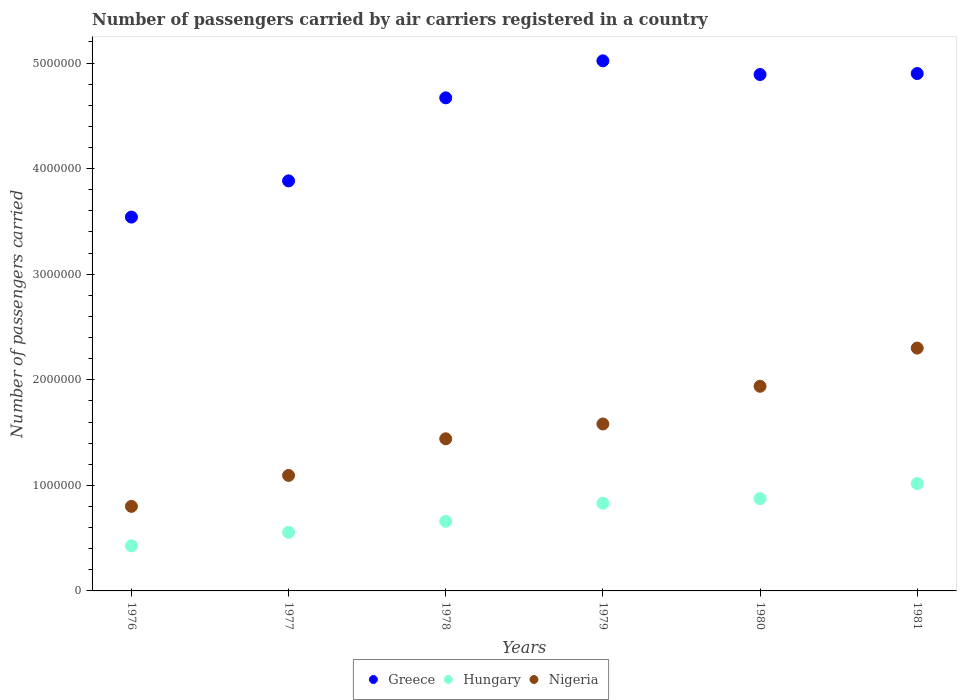How many different coloured dotlines are there?
Give a very brief answer. 3. What is the number of passengers carried by air carriers in Hungary in 1980?
Provide a succinct answer. 8.74e+05. Across all years, what is the maximum number of passengers carried by air carriers in Nigeria?
Offer a very short reply. 2.30e+06. Across all years, what is the minimum number of passengers carried by air carriers in Greece?
Your response must be concise. 3.54e+06. In which year was the number of passengers carried by air carriers in Greece maximum?
Ensure brevity in your answer.  1979. In which year was the number of passengers carried by air carriers in Nigeria minimum?
Your answer should be compact. 1976. What is the total number of passengers carried by air carriers in Nigeria in the graph?
Provide a short and direct response. 9.16e+06. What is the difference between the number of passengers carried by air carriers in Hungary in 1976 and that in 1980?
Offer a terse response. -4.47e+05. What is the difference between the number of passengers carried by air carriers in Greece in 1979 and the number of passengers carried by air carriers in Hungary in 1976?
Make the answer very short. 4.59e+06. What is the average number of passengers carried by air carriers in Hungary per year?
Your response must be concise. 7.27e+05. In the year 1977, what is the difference between the number of passengers carried by air carriers in Hungary and number of passengers carried by air carriers in Nigeria?
Provide a short and direct response. -5.39e+05. What is the ratio of the number of passengers carried by air carriers in Hungary in 1977 to that in 1980?
Offer a terse response. 0.63. Is the number of passengers carried by air carriers in Greece in 1976 less than that in 1977?
Your response must be concise. Yes. What is the difference between the highest and the second highest number of passengers carried by air carriers in Nigeria?
Your answer should be very brief. 3.62e+05. What is the difference between the highest and the lowest number of passengers carried by air carriers in Greece?
Give a very brief answer. 1.48e+06. Does the number of passengers carried by air carriers in Greece monotonically increase over the years?
Give a very brief answer. No. Is the number of passengers carried by air carriers in Hungary strictly greater than the number of passengers carried by air carriers in Nigeria over the years?
Your answer should be compact. No. Is the number of passengers carried by air carriers in Hungary strictly less than the number of passengers carried by air carriers in Greece over the years?
Your answer should be very brief. Yes. How many dotlines are there?
Your answer should be compact. 3. What is the difference between two consecutive major ticks on the Y-axis?
Make the answer very short. 1.00e+06. Does the graph contain any zero values?
Make the answer very short. No. Does the graph contain grids?
Give a very brief answer. No. How are the legend labels stacked?
Provide a short and direct response. Horizontal. What is the title of the graph?
Keep it short and to the point. Number of passengers carried by air carriers registered in a country. What is the label or title of the X-axis?
Provide a succinct answer. Years. What is the label or title of the Y-axis?
Your answer should be very brief. Number of passengers carried. What is the Number of passengers carried in Greece in 1976?
Offer a very short reply. 3.54e+06. What is the Number of passengers carried of Hungary in 1976?
Your answer should be very brief. 4.27e+05. What is the Number of passengers carried in Nigeria in 1976?
Keep it short and to the point. 8.01e+05. What is the Number of passengers carried of Greece in 1977?
Keep it short and to the point. 3.88e+06. What is the Number of passengers carried of Hungary in 1977?
Offer a very short reply. 5.55e+05. What is the Number of passengers carried of Nigeria in 1977?
Your response must be concise. 1.09e+06. What is the Number of passengers carried in Greece in 1978?
Provide a short and direct response. 4.67e+06. What is the Number of passengers carried in Hungary in 1978?
Give a very brief answer. 6.59e+05. What is the Number of passengers carried in Nigeria in 1978?
Offer a terse response. 1.44e+06. What is the Number of passengers carried in Greece in 1979?
Your response must be concise. 5.02e+06. What is the Number of passengers carried in Hungary in 1979?
Make the answer very short. 8.30e+05. What is the Number of passengers carried of Nigeria in 1979?
Provide a succinct answer. 1.58e+06. What is the Number of passengers carried in Greece in 1980?
Your answer should be very brief. 4.89e+06. What is the Number of passengers carried of Hungary in 1980?
Your answer should be compact. 8.74e+05. What is the Number of passengers carried of Nigeria in 1980?
Provide a short and direct response. 1.94e+06. What is the Number of passengers carried of Greece in 1981?
Your response must be concise. 4.90e+06. What is the Number of passengers carried of Hungary in 1981?
Offer a terse response. 1.02e+06. What is the Number of passengers carried of Nigeria in 1981?
Ensure brevity in your answer.  2.30e+06. Across all years, what is the maximum Number of passengers carried in Greece?
Provide a succinct answer. 5.02e+06. Across all years, what is the maximum Number of passengers carried of Hungary?
Offer a very short reply. 1.02e+06. Across all years, what is the maximum Number of passengers carried in Nigeria?
Your response must be concise. 2.30e+06. Across all years, what is the minimum Number of passengers carried of Greece?
Your answer should be very brief. 3.54e+06. Across all years, what is the minimum Number of passengers carried of Hungary?
Provide a succinct answer. 4.27e+05. Across all years, what is the minimum Number of passengers carried in Nigeria?
Offer a terse response. 8.01e+05. What is the total Number of passengers carried of Greece in the graph?
Provide a short and direct response. 2.69e+07. What is the total Number of passengers carried of Hungary in the graph?
Give a very brief answer. 4.36e+06. What is the total Number of passengers carried of Nigeria in the graph?
Keep it short and to the point. 9.16e+06. What is the difference between the Number of passengers carried in Greece in 1976 and that in 1977?
Offer a terse response. -3.43e+05. What is the difference between the Number of passengers carried in Hungary in 1976 and that in 1977?
Provide a short and direct response. -1.28e+05. What is the difference between the Number of passengers carried in Nigeria in 1976 and that in 1977?
Ensure brevity in your answer.  -2.93e+05. What is the difference between the Number of passengers carried of Greece in 1976 and that in 1978?
Keep it short and to the point. -1.13e+06. What is the difference between the Number of passengers carried of Hungary in 1976 and that in 1978?
Ensure brevity in your answer.  -2.32e+05. What is the difference between the Number of passengers carried in Nigeria in 1976 and that in 1978?
Your response must be concise. -6.40e+05. What is the difference between the Number of passengers carried in Greece in 1976 and that in 1979?
Offer a very short reply. -1.48e+06. What is the difference between the Number of passengers carried in Hungary in 1976 and that in 1979?
Your answer should be very brief. -4.03e+05. What is the difference between the Number of passengers carried in Nigeria in 1976 and that in 1979?
Make the answer very short. -7.80e+05. What is the difference between the Number of passengers carried in Greece in 1976 and that in 1980?
Ensure brevity in your answer.  -1.35e+06. What is the difference between the Number of passengers carried of Hungary in 1976 and that in 1980?
Offer a very short reply. -4.47e+05. What is the difference between the Number of passengers carried of Nigeria in 1976 and that in 1980?
Your answer should be very brief. -1.14e+06. What is the difference between the Number of passengers carried of Greece in 1976 and that in 1981?
Provide a short and direct response. -1.36e+06. What is the difference between the Number of passengers carried in Hungary in 1976 and that in 1981?
Your response must be concise. -5.90e+05. What is the difference between the Number of passengers carried in Nigeria in 1976 and that in 1981?
Offer a very short reply. -1.50e+06. What is the difference between the Number of passengers carried of Greece in 1977 and that in 1978?
Your answer should be very brief. -7.87e+05. What is the difference between the Number of passengers carried of Hungary in 1977 and that in 1978?
Offer a terse response. -1.04e+05. What is the difference between the Number of passengers carried in Nigeria in 1977 and that in 1978?
Make the answer very short. -3.47e+05. What is the difference between the Number of passengers carried of Greece in 1977 and that in 1979?
Ensure brevity in your answer.  -1.14e+06. What is the difference between the Number of passengers carried in Hungary in 1977 and that in 1979?
Offer a terse response. -2.75e+05. What is the difference between the Number of passengers carried in Nigeria in 1977 and that in 1979?
Make the answer very short. -4.87e+05. What is the difference between the Number of passengers carried of Greece in 1977 and that in 1980?
Your answer should be very brief. -1.01e+06. What is the difference between the Number of passengers carried in Hungary in 1977 and that in 1980?
Provide a short and direct response. -3.19e+05. What is the difference between the Number of passengers carried of Nigeria in 1977 and that in 1980?
Your answer should be compact. -8.45e+05. What is the difference between the Number of passengers carried of Greece in 1977 and that in 1981?
Your answer should be compact. -1.02e+06. What is the difference between the Number of passengers carried in Hungary in 1977 and that in 1981?
Your response must be concise. -4.62e+05. What is the difference between the Number of passengers carried in Nigeria in 1977 and that in 1981?
Ensure brevity in your answer.  -1.21e+06. What is the difference between the Number of passengers carried in Greece in 1978 and that in 1979?
Provide a succinct answer. -3.51e+05. What is the difference between the Number of passengers carried in Hungary in 1978 and that in 1979?
Your answer should be compact. -1.71e+05. What is the difference between the Number of passengers carried of Nigeria in 1978 and that in 1979?
Provide a succinct answer. -1.40e+05. What is the difference between the Number of passengers carried of Greece in 1978 and that in 1980?
Make the answer very short. -2.21e+05. What is the difference between the Number of passengers carried in Hungary in 1978 and that in 1980?
Make the answer very short. -2.15e+05. What is the difference between the Number of passengers carried in Nigeria in 1978 and that in 1980?
Give a very brief answer. -4.98e+05. What is the difference between the Number of passengers carried in Greece in 1978 and that in 1981?
Your answer should be compact. -2.30e+05. What is the difference between the Number of passengers carried in Hungary in 1978 and that in 1981?
Keep it short and to the point. -3.58e+05. What is the difference between the Number of passengers carried in Nigeria in 1978 and that in 1981?
Give a very brief answer. -8.59e+05. What is the difference between the Number of passengers carried of Greece in 1979 and that in 1980?
Give a very brief answer. 1.30e+05. What is the difference between the Number of passengers carried in Hungary in 1979 and that in 1980?
Keep it short and to the point. -4.41e+04. What is the difference between the Number of passengers carried in Nigeria in 1979 and that in 1980?
Your answer should be compact. -3.57e+05. What is the difference between the Number of passengers carried of Greece in 1979 and that in 1981?
Ensure brevity in your answer.  1.20e+05. What is the difference between the Number of passengers carried of Hungary in 1979 and that in 1981?
Your answer should be very brief. -1.87e+05. What is the difference between the Number of passengers carried in Nigeria in 1979 and that in 1981?
Provide a succinct answer. -7.19e+05. What is the difference between the Number of passengers carried in Greece in 1980 and that in 1981?
Provide a short and direct response. -9400. What is the difference between the Number of passengers carried in Hungary in 1980 and that in 1981?
Your answer should be compact. -1.43e+05. What is the difference between the Number of passengers carried of Nigeria in 1980 and that in 1981?
Make the answer very short. -3.62e+05. What is the difference between the Number of passengers carried in Greece in 1976 and the Number of passengers carried in Hungary in 1977?
Your response must be concise. 2.99e+06. What is the difference between the Number of passengers carried of Greece in 1976 and the Number of passengers carried of Nigeria in 1977?
Your response must be concise. 2.45e+06. What is the difference between the Number of passengers carried of Hungary in 1976 and the Number of passengers carried of Nigeria in 1977?
Your answer should be compact. -6.67e+05. What is the difference between the Number of passengers carried of Greece in 1976 and the Number of passengers carried of Hungary in 1978?
Ensure brevity in your answer.  2.88e+06. What is the difference between the Number of passengers carried in Greece in 1976 and the Number of passengers carried in Nigeria in 1978?
Provide a short and direct response. 2.10e+06. What is the difference between the Number of passengers carried in Hungary in 1976 and the Number of passengers carried in Nigeria in 1978?
Your answer should be very brief. -1.01e+06. What is the difference between the Number of passengers carried in Greece in 1976 and the Number of passengers carried in Hungary in 1979?
Your answer should be compact. 2.71e+06. What is the difference between the Number of passengers carried of Greece in 1976 and the Number of passengers carried of Nigeria in 1979?
Your response must be concise. 1.96e+06. What is the difference between the Number of passengers carried in Hungary in 1976 and the Number of passengers carried in Nigeria in 1979?
Offer a very short reply. -1.15e+06. What is the difference between the Number of passengers carried of Greece in 1976 and the Number of passengers carried of Hungary in 1980?
Provide a short and direct response. 2.67e+06. What is the difference between the Number of passengers carried in Greece in 1976 and the Number of passengers carried in Nigeria in 1980?
Offer a terse response. 1.60e+06. What is the difference between the Number of passengers carried in Hungary in 1976 and the Number of passengers carried in Nigeria in 1980?
Provide a succinct answer. -1.51e+06. What is the difference between the Number of passengers carried of Greece in 1976 and the Number of passengers carried of Hungary in 1981?
Offer a terse response. 2.52e+06. What is the difference between the Number of passengers carried of Greece in 1976 and the Number of passengers carried of Nigeria in 1981?
Make the answer very short. 1.24e+06. What is the difference between the Number of passengers carried of Hungary in 1976 and the Number of passengers carried of Nigeria in 1981?
Your response must be concise. -1.87e+06. What is the difference between the Number of passengers carried in Greece in 1977 and the Number of passengers carried in Hungary in 1978?
Provide a succinct answer. 3.22e+06. What is the difference between the Number of passengers carried of Greece in 1977 and the Number of passengers carried of Nigeria in 1978?
Your answer should be very brief. 2.44e+06. What is the difference between the Number of passengers carried of Hungary in 1977 and the Number of passengers carried of Nigeria in 1978?
Give a very brief answer. -8.86e+05. What is the difference between the Number of passengers carried in Greece in 1977 and the Number of passengers carried in Hungary in 1979?
Provide a succinct answer. 3.05e+06. What is the difference between the Number of passengers carried of Greece in 1977 and the Number of passengers carried of Nigeria in 1979?
Make the answer very short. 2.30e+06. What is the difference between the Number of passengers carried in Hungary in 1977 and the Number of passengers carried in Nigeria in 1979?
Your answer should be compact. -1.03e+06. What is the difference between the Number of passengers carried of Greece in 1977 and the Number of passengers carried of Hungary in 1980?
Offer a terse response. 3.01e+06. What is the difference between the Number of passengers carried in Greece in 1977 and the Number of passengers carried in Nigeria in 1980?
Keep it short and to the point. 1.95e+06. What is the difference between the Number of passengers carried of Hungary in 1977 and the Number of passengers carried of Nigeria in 1980?
Ensure brevity in your answer.  -1.38e+06. What is the difference between the Number of passengers carried of Greece in 1977 and the Number of passengers carried of Hungary in 1981?
Keep it short and to the point. 2.87e+06. What is the difference between the Number of passengers carried in Greece in 1977 and the Number of passengers carried in Nigeria in 1981?
Give a very brief answer. 1.58e+06. What is the difference between the Number of passengers carried in Hungary in 1977 and the Number of passengers carried in Nigeria in 1981?
Your answer should be compact. -1.75e+06. What is the difference between the Number of passengers carried of Greece in 1978 and the Number of passengers carried of Hungary in 1979?
Keep it short and to the point. 3.84e+06. What is the difference between the Number of passengers carried in Greece in 1978 and the Number of passengers carried in Nigeria in 1979?
Offer a very short reply. 3.09e+06. What is the difference between the Number of passengers carried in Hungary in 1978 and the Number of passengers carried in Nigeria in 1979?
Ensure brevity in your answer.  -9.22e+05. What is the difference between the Number of passengers carried in Greece in 1978 and the Number of passengers carried in Hungary in 1980?
Provide a succinct answer. 3.80e+06. What is the difference between the Number of passengers carried in Greece in 1978 and the Number of passengers carried in Nigeria in 1980?
Offer a very short reply. 2.73e+06. What is the difference between the Number of passengers carried of Hungary in 1978 and the Number of passengers carried of Nigeria in 1980?
Offer a terse response. -1.28e+06. What is the difference between the Number of passengers carried of Greece in 1978 and the Number of passengers carried of Hungary in 1981?
Provide a short and direct response. 3.65e+06. What is the difference between the Number of passengers carried of Greece in 1978 and the Number of passengers carried of Nigeria in 1981?
Your answer should be compact. 2.37e+06. What is the difference between the Number of passengers carried of Hungary in 1978 and the Number of passengers carried of Nigeria in 1981?
Your answer should be compact. -1.64e+06. What is the difference between the Number of passengers carried of Greece in 1979 and the Number of passengers carried of Hungary in 1980?
Provide a succinct answer. 4.15e+06. What is the difference between the Number of passengers carried in Greece in 1979 and the Number of passengers carried in Nigeria in 1980?
Keep it short and to the point. 3.08e+06. What is the difference between the Number of passengers carried in Hungary in 1979 and the Number of passengers carried in Nigeria in 1980?
Your answer should be very brief. -1.11e+06. What is the difference between the Number of passengers carried of Greece in 1979 and the Number of passengers carried of Hungary in 1981?
Ensure brevity in your answer.  4.00e+06. What is the difference between the Number of passengers carried in Greece in 1979 and the Number of passengers carried in Nigeria in 1981?
Your answer should be compact. 2.72e+06. What is the difference between the Number of passengers carried in Hungary in 1979 and the Number of passengers carried in Nigeria in 1981?
Your response must be concise. -1.47e+06. What is the difference between the Number of passengers carried in Greece in 1980 and the Number of passengers carried in Hungary in 1981?
Ensure brevity in your answer.  3.87e+06. What is the difference between the Number of passengers carried of Greece in 1980 and the Number of passengers carried of Nigeria in 1981?
Your answer should be very brief. 2.59e+06. What is the difference between the Number of passengers carried of Hungary in 1980 and the Number of passengers carried of Nigeria in 1981?
Offer a very short reply. -1.43e+06. What is the average Number of passengers carried of Greece per year?
Your answer should be very brief. 4.48e+06. What is the average Number of passengers carried in Hungary per year?
Make the answer very short. 7.27e+05. What is the average Number of passengers carried of Nigeria per year?
Give a very brief answer. 1.53e+06. In the year 1976, what is the difference between the Number of passengers carried of Greece and Number of passengers carried of Hungary?
Provide a succinct answer. 3.11e+06. In the year 1976, what is the difference between the Number of passengers carried in Greece and Number of passengers carried in Nigeria?
Ensure brevity in your answer.  2.74e+06. In the year 1976, what is the difference between the Number of passengers carried of Hungary and Number of passengers carried of Nigeria?
Provide a succinct answer. -3.74e+05. In the year 1977, what is the difference between the Number of passengers carried in Greece and Number of passengers carried in Hungary?
Offer a very short reply. 3.33e+06. In the year 1977, what is the difference between the Number of passengers carried in Greece and Number of passengers carried in Nigeria?
Offer a terse response. 2.79e+06. In the year 1977, what is the difference between the Number of passengers carried of Hungary and Number of passengers carried of Nigeria?
Offer a very short reply. -5.39e+05. In the year 1978, what is the difference between the Number of passengers carried of Greece and Number of passengers carried of Hungary?
Provide a short and direct response. 4.01e+06. In the year 1978, what is the difference between the Number of passengers carried of Greece and Number of passengers carried of Nigeria?
Give a very brief answer. 3.23e+06. In the year 1978, what is the difference between the Number of passengers carried in Hungary and Number of passengers carried in Nigeria?
Offer a terse response. -7.82e+05. In the year 1979, what is the difference between the Number of passengers carried of Greece and Number of passengers carried of Hungary?
Ensure brevity in your answer.  4.19e+06. In the year 1979, what is the difference between the Number of passengers carried in Greece and Number of passengers carried in Nigeria?
Ensure brevity in your answer.  3.44e+06. In the year 1979, what is the difference between the Number of passengers carried of Hungary and Number of passengers carried of Nigeria?
Offer a terse response. -7.51e+05. In the year 1980, what is the difference between the Number of passengers carried of Greece and Number of passengers carried of Hungary?
Your answer should be very brief. 4.02e+06. In the year 1980, what is the difference between the Number of passengers carried of Greece and Number of passengers carried of Nigeria?
Provide a short and direct response. 2.95e+06. In the year 1980, what is the difference between the Number of passengers carried in Hungary and Number of passengers carried in Nigeria?
Keep it short and to the point. -1.06e+06. In the year 1981, what is the difference between the Number of passengers carried in Greece and Number of passengers carried in Hungary?
Give a very brief answer. 3.88e+06. In the year 1981, what is the difference between the Number of passengers carried in Greece and Number of passengers carried in Nigeria?
Keep it short and to the point. 2.60e+06. In the year 1981, what is the difference between the Number of passengers carried in Hungary and Number of passengers carried in Nigeria?
Your answer should be very brief. -1.28e+06. What is the ratio of the Number of passengers carried of Greece in 1976 to that in 1977?
Provide a short and direct response. 0.91. What is the ratio of the Number of passengers carried in Hungary in 1976 to that in 1977?
Make the answer very short. 0.77. What is the ratio of the Number of passengers carried of Nigeria in 1976 to that in 1977?
Your response must be concise. 0.73. What is the ratio of the Number of passengers carried of Greece in 1976 to that in 1978?
Keep it short and to the point. 0.76. What is the ratio of the Number of passengers carried of Hungary in 1976 to that in 1978?
Your answer should be compact. 0.65. What is the ratio of the Number of passengers carried in Nigeria in 1976 to that in 1978?
Offer a terse response. 0.56. What is the ratio of the Number of passengers carried in Greece in 1976 to that in 1979?
Offer a terse response. 0.71. What is the ratio of the Number of passengers carried in Hungary in 1976 to that in 1979?
Keep it short and to the point. 0.51. What is the ratio of the Number of passengers carried of Nigeria in 1976 to that in 1979?
Keep it short and to the point. 0.51. What is the ratio of the Number of passengers carried in Greece in 1976 to that in 1980?
Give a very brief answer. 0.72. What is the ratio of the Number of passengers carried in Hungary in 1976 to that in 1980?
Give a very brief answer. 0.49. What is the ratio of the Number of passengers carried in Nigeria in 1976 to that in 1980?
Provide a short and direct response. 0.41. What is the ratio of the Number of passengers carried in Greece in 1976 to that in 1981?
Make the answer very short. 0.72. What is the ratio of the Number of passengers carried in Hungary in 1976 to that in 1981?
Make the answer very short. 0.42. What is the ratio of the Number of passengers carried in Nigeria in 1976 to that in 1981?
Give a very brief answer. 0.35. What is the ratio of the Number of passengers carried in Greece in 1977 to that in 1978?
Your answer should be very brief. 0.83. What is the ratio of the Number of passengers carried of Hungary in 1977 to that in 1978?
Give a very brief answer. 0.84. What is the ratio of the Number of passengers carried in Nigeria in 1977 to that in 1978?
Make the answer very short. 0.76. What is the ratio of the Number of passengers carried of Greece in 1977 to that in 1979?
Give a very brief answer. 0.77. What is the ratio of the Number of passengers carried of Hungary in 1977 to that in 1979?
Your answer should be very brief. 0.67. What is the ratio of the Number of passengers carried of Nigeria in 1977 to that in 1979?
Make the answer very short. 0.69. What is the ratio of the Number of passengers carried in Greece in 1977 to that in 1980?
Give a very brief answer. 0.79. What is the ratio of the Number of passengers carried of Hungary in 1977 to that in 1980?
Your answer should be compact. 0.63. What is the ratio of the Number of passengers carried in Nigeria in 1977 to that in 1980?
Provide a short and direct response. 0.56. What is the ratio of the Number of passengers carried in Greece in 1977 to that in 1981?
Make the answer very short. 0.79. What is the ratio of the Number of passengers carried of Hungary in 1977 to that in 1981?
Ensure brevity in your answer.  0.55. What is the ratio of the Number of passengers carried in Nigeria in 1977 to that in 1981?
Provide a succinct answer. 0.48. What is the ratio of the Number of passengers carried of Greece in 1978 to that in 1979?
Offer a terse response. 0.93. What is the ratio of the Number of passengers carried in Hungary in 1978 to that in 1979?
Give a very brief answer. 0.79. What is the ratio of the Number of passengers carried in Nigeria in 1978 to that in 1979?
Your answer should be compact. 0.91. What is the ratio of the Number of passengers carried in Greece in 1978 to that in 1980?
Your answer should be very brief. 0.95. What is the ratio of the Number of passengers carried of Hungary in 1978 to that in 1980?
Your answer should be compact. 0.75. What is the ratio of the Number of passengers carried of Nigeria in 1978 to that in 1980?
Ensure brevity in your answer.  0.74. What is the ratio of the Number of passengers carried of Greece in 1978 to that in 1981?
Keep it short and to the point. 0.95. What is the ratio of the Number of passengers carried in Hungary in 1978 to that in 1981?
Give a very brief answer. 0.65. What is the ratio of the Number of passengers carried in Nigeria in 1978 to that in 1981?
Ensure brevity in your answer.  0.63. What is the ratio of the Number of passengers carried of Greece in 1979 to that in 1980?
Give a very brief answer. 1.03. What is the ratio of the Number of passengers carried of Hungary in 1979 to that in 1980?
Provide a succinct answer. 0.95. What is the ratio of the Number of passengers carried of Nigeria in 1979 to that in 1980?
Provide a short and direct response. 0.82. What is the ratio of the Number of passengers carried in Greece in 1979 to that in 1981?
Offer a very short reply. 1.02. What is the ratio of the Number of passengers carried of Hungary in 1979 to that in 1981?
Provide a short and direct response. 0.82. What is the ratio of the Number of passengers carried of Nigeria in 1979 to that in 1981?
Keep it short and to the point. 0.69. What is the ratio of the Number of passengers carried of Greece in 1980 to that in 1981?
Offer a terse response. 1. What is the ratio of the Number of passengers carried of Hungary in 1980 to that in 1981?
Ensure brevity in your answer.  0.86. What is the ratio of the Number of passengers carried of Nigeria in 1980 to that in 1981?
Ensure brevity in your answer.  0.84. What is the difference between the highest and the second highest Number of passengers carried in Greece?
Your answer should be very brief. 1.20e+05. What is the difference between the highest and the second highest Number of passengers carried in Hungary?
Your answer should be compact. 1.43e+05. What is the difference between the highest and the second highest Number of passengers carried in Nigeria?
Your answer should be compact. 3.62e+05. What is the difference between the highest and the lowest Number of passengers carried of Greece?
Your answer should be very brief. 1.48e+06. What is the difference between the highest and the lowest Number of passengers carried of Hungary?
Your response must be concise. 5.90e+05. What is the difference between the highest and the lowest Number of passengers carried in Nigeria?
Make the answer very short. 1.50e+06. 